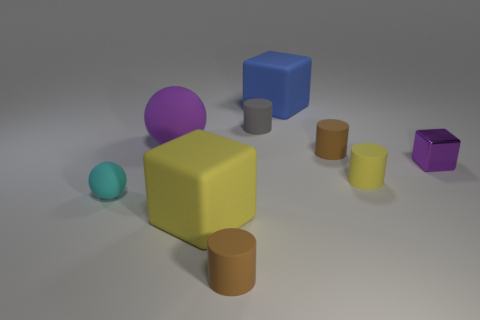Subtract all big blocks. How many blocks are left? 1 Subtract all purple blocks. How many brown cylinders are left? 2 Subtract all yellow cylinders. How many cylinders are left? 3 Add 1 large gray rubber cubes. How many objects exist? 10 Subtract all purple cylinders. Subtract all gray cubes. How many cylinders are left? 4 Subtract all small brown rubber cubes. Subtract all tiny yellow matte objects. How many objects are left? 8 Add 4 tiny cylinders. How many tiny cylinders are left? 8 Add 8 tiny gray things. How many tiny gray things exist? 9 Subtract 0 yellow spheres. How many objects are left? 9 Subtract all spheres. How many objects are left? 7 